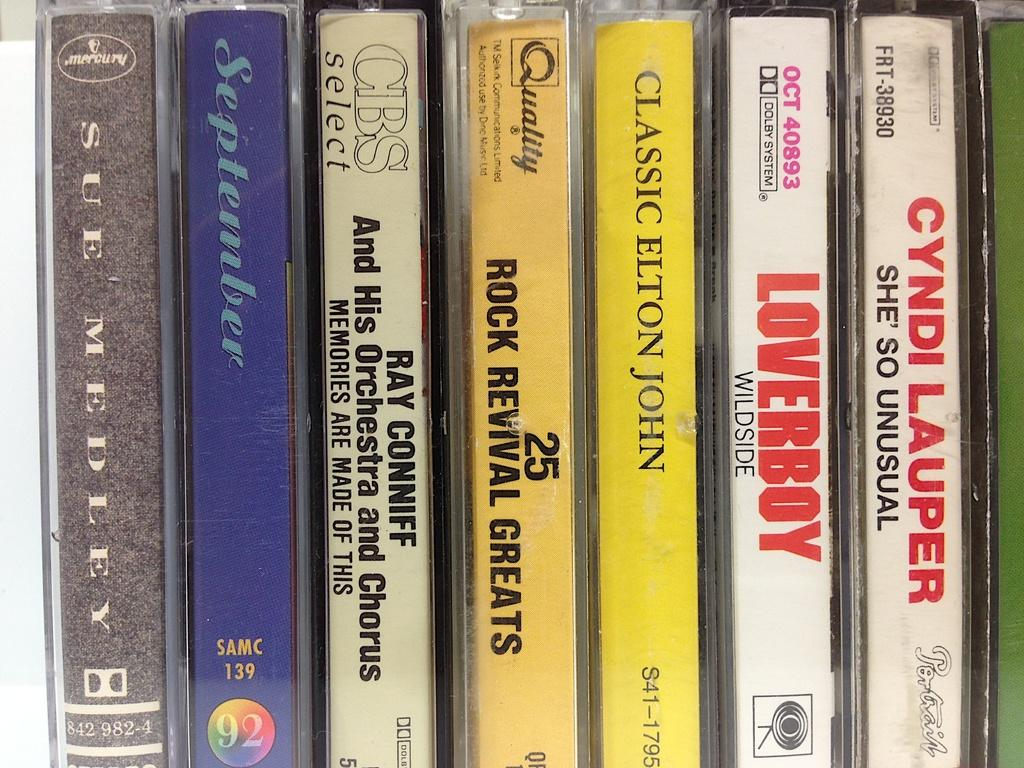<image>
Offer a succinct explanation of the picture presented. A set of old cassettes, one of which is called September. 